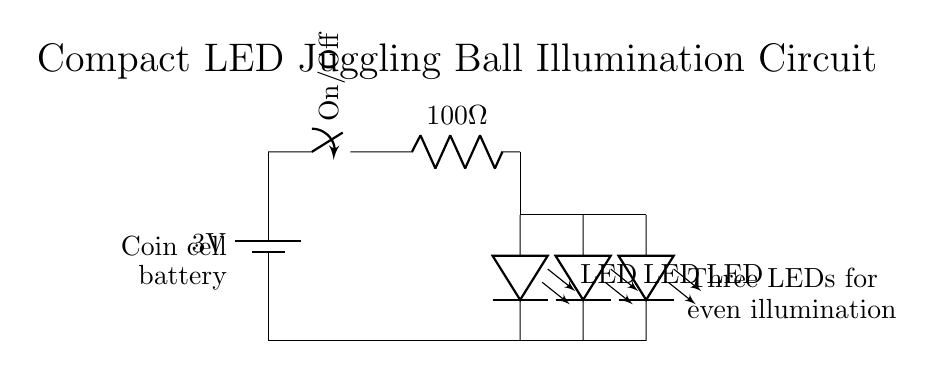What is the voltage of the power supply? The voltage of the power supply is indicated next to the battery symbol as three volts. This can be seen in the circuit diagram near the coin cell battery.
Answer: three volts How many LEDs are connected in this circuit? There are three LEDs connected in parallel in this circuit. The diagram shows three LED symbols, each connected individually to the same voltage source.
Answer: three What is the resistance value of the resistor in the circuit? The resistance value is shown next to the resistor symbol, which is labeled as one hundred ohms. This indicates the resistance value for current limiting purposes in the circuit.
Answer: one hundred ohms What is the purpose of the resistor in this circuit? The resistor serves to limit the current flowing through the LEDs, preventing them from burning out. Since LEDs are sensitive to current levels, the resistor ensures safe operation.
Answer: limit current What type of switch is used in this circuit? The switch is a toggle switch, indicated by the symbol for a switch in the diagram. Toggle switches allow the user to open or close the circuit for the LEDs to turn on or off.
Answer: toggle switch 